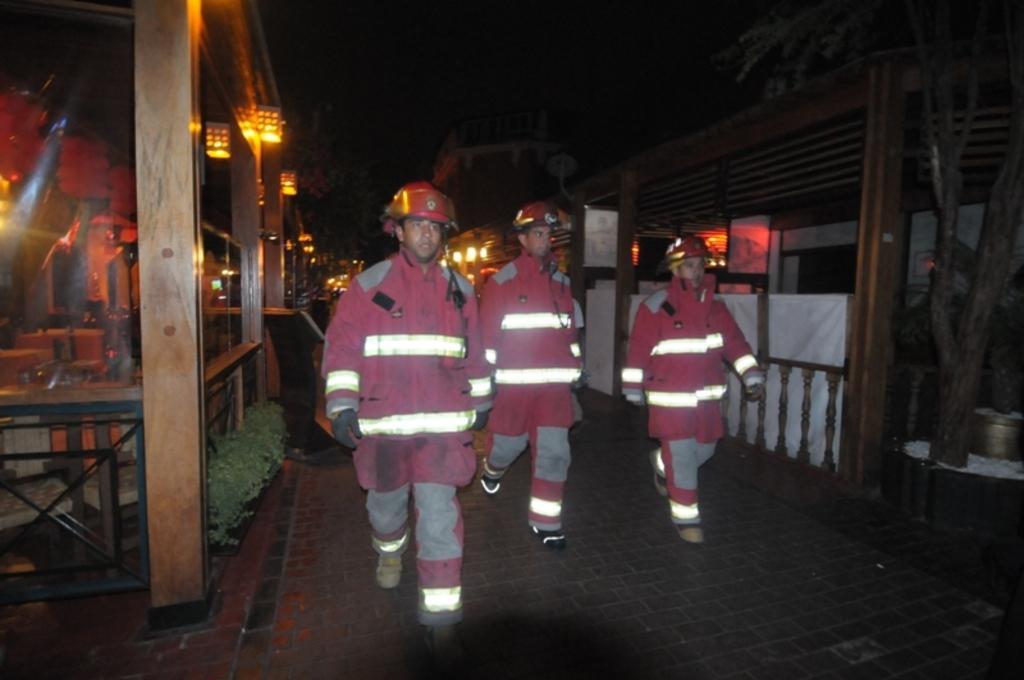How would you summarize this image in a sentence or two? At the bottom of this image, there are three persons, wearing caps and walking on the road. On the left side, there are wooden pillars, lights attached to the roof, a fence, plants and other objects. On the right side, there is a fence, a tree, lights attached to the roof and other objects. In the background, there are lights. 